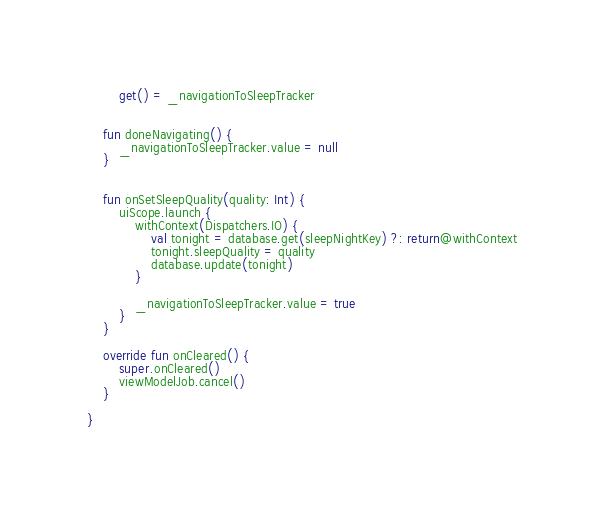Convert code to text. <code><loc_0><loc_0><loc_500><loc_500><_Kotlin_>        get() = _navigationToSleepTracker


    fun doneNavigating() {
        _navigationToSleepTracker.value = null
    }


    fun onSetSleepQuality(quality: Int) {
        uiScope.launch {
            withContext(Dispatchers.IO) {
                val tonight = database.get(sleepNightKey) ?: return@withContext
                tonight.sleepQuality = quality
                database.update(tonight)
            }

            _navigationToSleepTracker.value = true
        }
    }

    override fun onCleared() {
        super.onCleared()
        viewModelJob.cancel()
    }

}</code> 